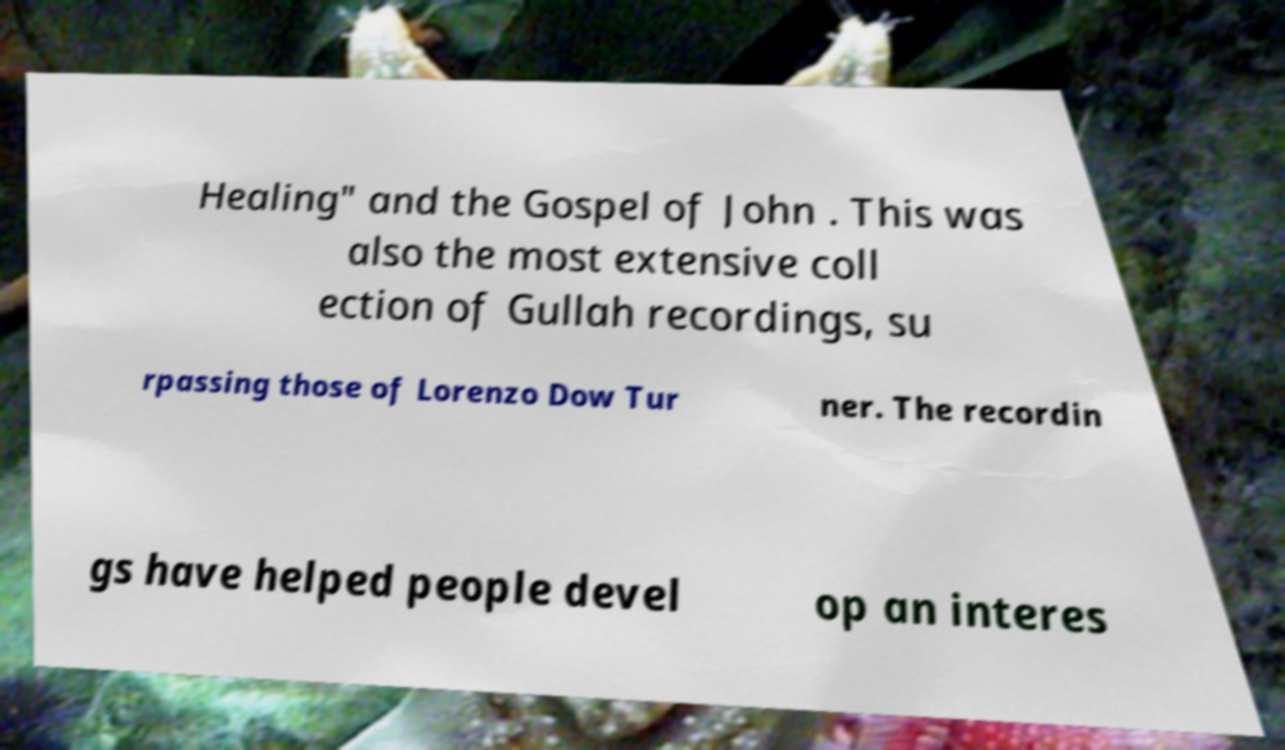There's text embedded in this image that I need extracted. Can you transcribe it verbatim? Healing" and the Gospel of John . This was also the most extensive coll ection of Gullah recordings, su rpassing those of Lorenzo Dow Tur ner. The recordin gs have helped people devel op an interes 